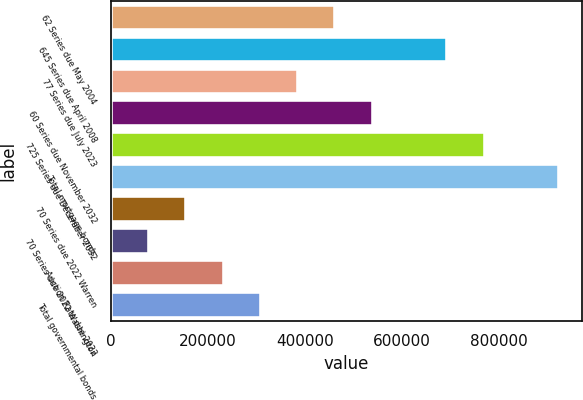<chart> <loc_0><loc_0><loc_500><loc_500><bar_chart><fcel>62 Series due May 2004<fcel>645 Series due April 2008<fcel>77 Series due July 2023<fcel>60 Series due November 2032<fcel>725 Series due December 2032<fcel>Total mortgage bonds<fcel>70 Series due 2022 Warren<fcel>70 Series due 2022 Washington<fcel>Auction Rate due 2022<fcel>Total governmental bonds<nl><fcel>463271<fcel>694369<fcel>386238<fcel>540304<fcel>771402<fcel>925468<fcel>155140<fcel>78106.8<fcel>232172<fcel>309205<nl></chart> 